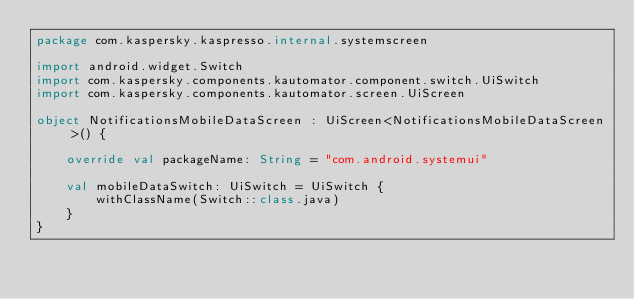Convert code to text. <code><loc_0><loc_0><loc_500><loc_500><_Kotlin_>package com.kaspersky.kaspresso.internal.systemscreen

import android.widget.Switch
import com.kaspersky.components.kautomator.component.switch.UiSwitch
import com.kaspersky.components.kautomator.screen.UiScreen

object NotificationsMobileDataScreen : UiScreen<NotificationsMobileDataScreen>() {

    override val packageName: String = "com.android.systemui"

    val mobileDataSwitch: UiSwitch = UiSwitch {
        withClassName(Switch::class.java)
    }
}
</code> 